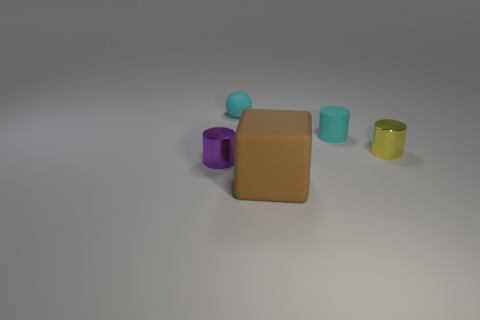Is there any other thing that is the same size as the brown cube?
Your response must be concise. No. How big is the matte thing that is in front of the shiny cylinder left of the metal thing behind the purple shiny object?
Offer a very short reply. Large. Is the size of the purple cylinder the same as the matte object in front of the purple cylinder?
Keep it short and to the point. No. What number of tiny objects are the same color as the matte cylinder?
Offer a terse response. 1. Are there fewer cyan cylinders than tiny gray blocks?
Provide a short and direct response. No. Are the big thing and the cyan ball made of the same material?
Give a very brief answer. Yes. How many other objects are there of the same size as the brown matte object?
Provide a short and direct response. 0. What is the color of the small metal cylinder on the right side of the cylinder in front of the yellow shiny object?
Keep it short and to the point. Yellow. What number of other objects are there of the same shape as the large object?
Your response must be concise. 0. Is there a thing that has the same material as the big block?
Offer a very short reply. Yes. 